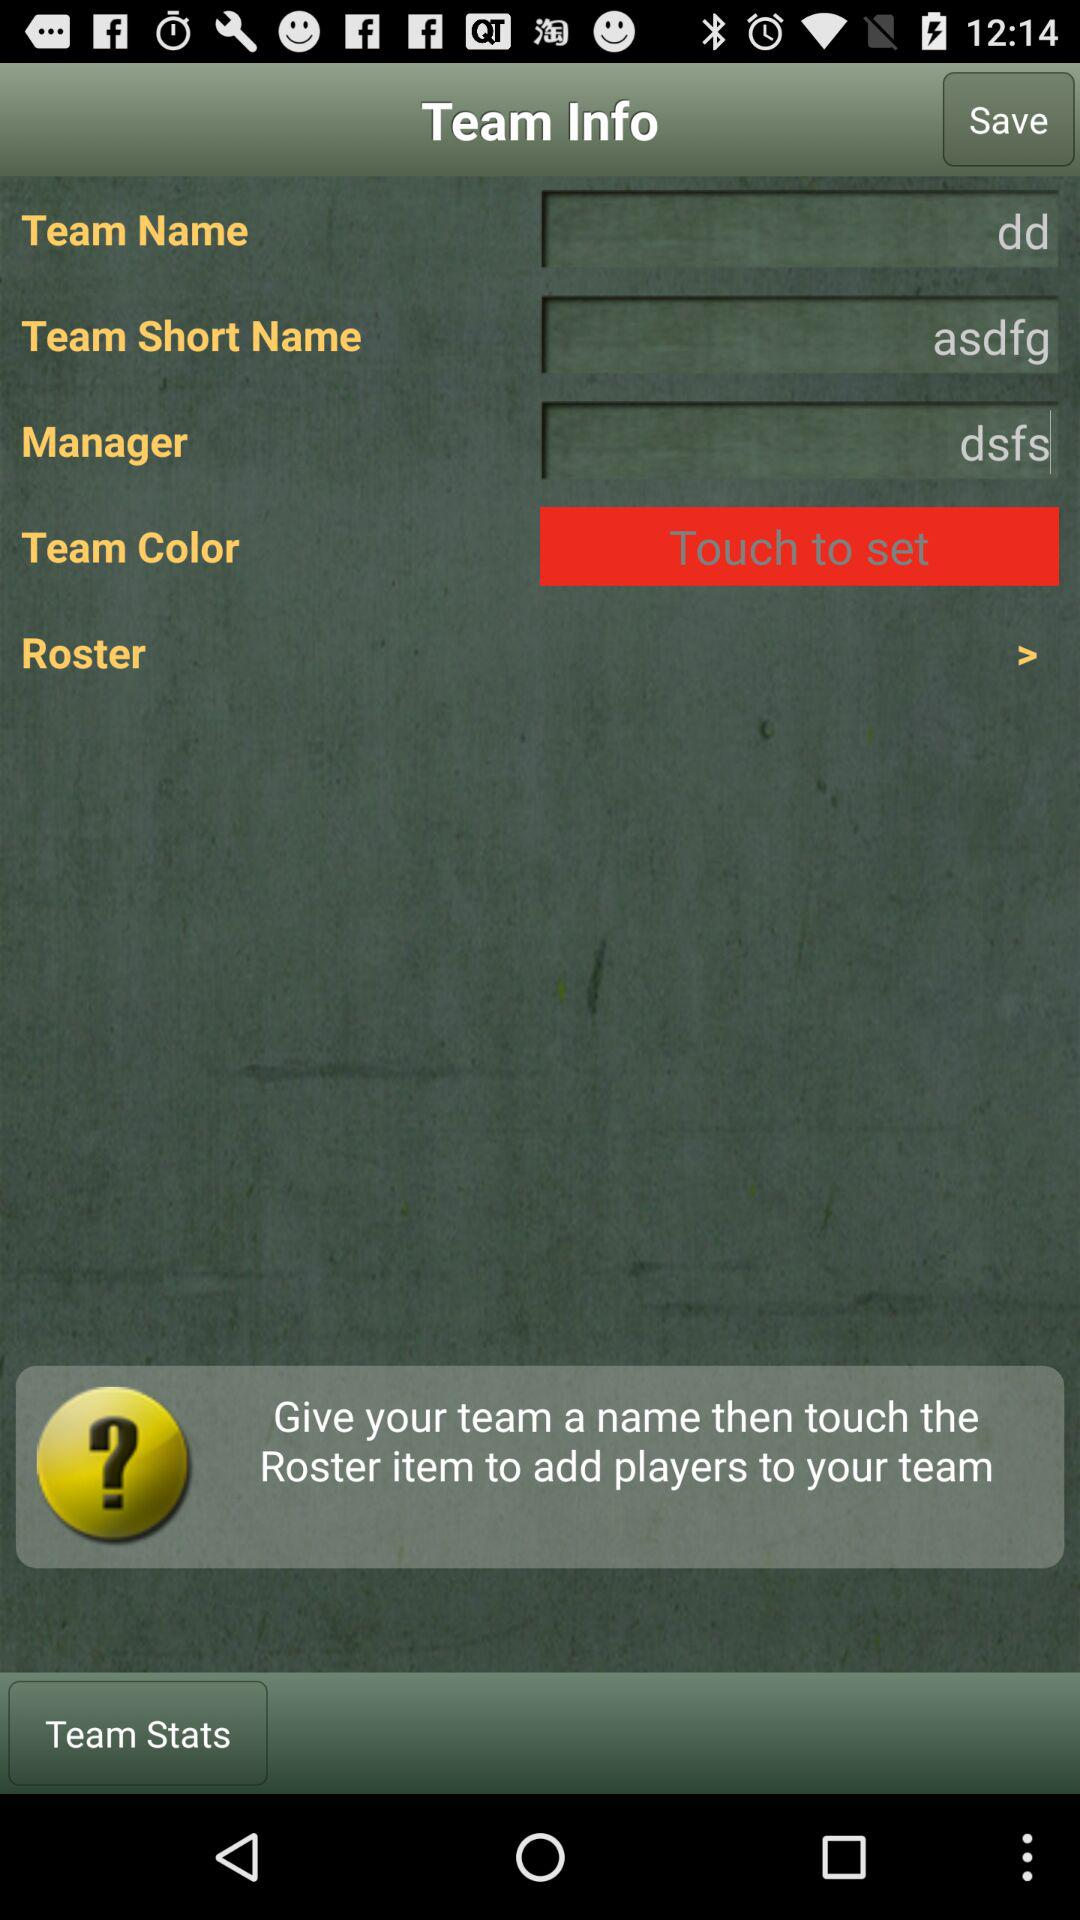How many text inputs are in the team info section?
Answer the question using a single word or phrase. 3 